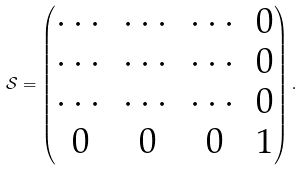<formula> <loc_0><loc_0><loc_500><loc_500>\mathcal { S } = \begin{pmatrix} \cdots & \cdots & \cdots & 0 \\ \cdots & \cdots & \cdots & 0 \\ \cdots & \cdots & \cdots & 0 \\ 0 & 0 & 0 & 1 \\ \end{pmatrix} .</formula> 